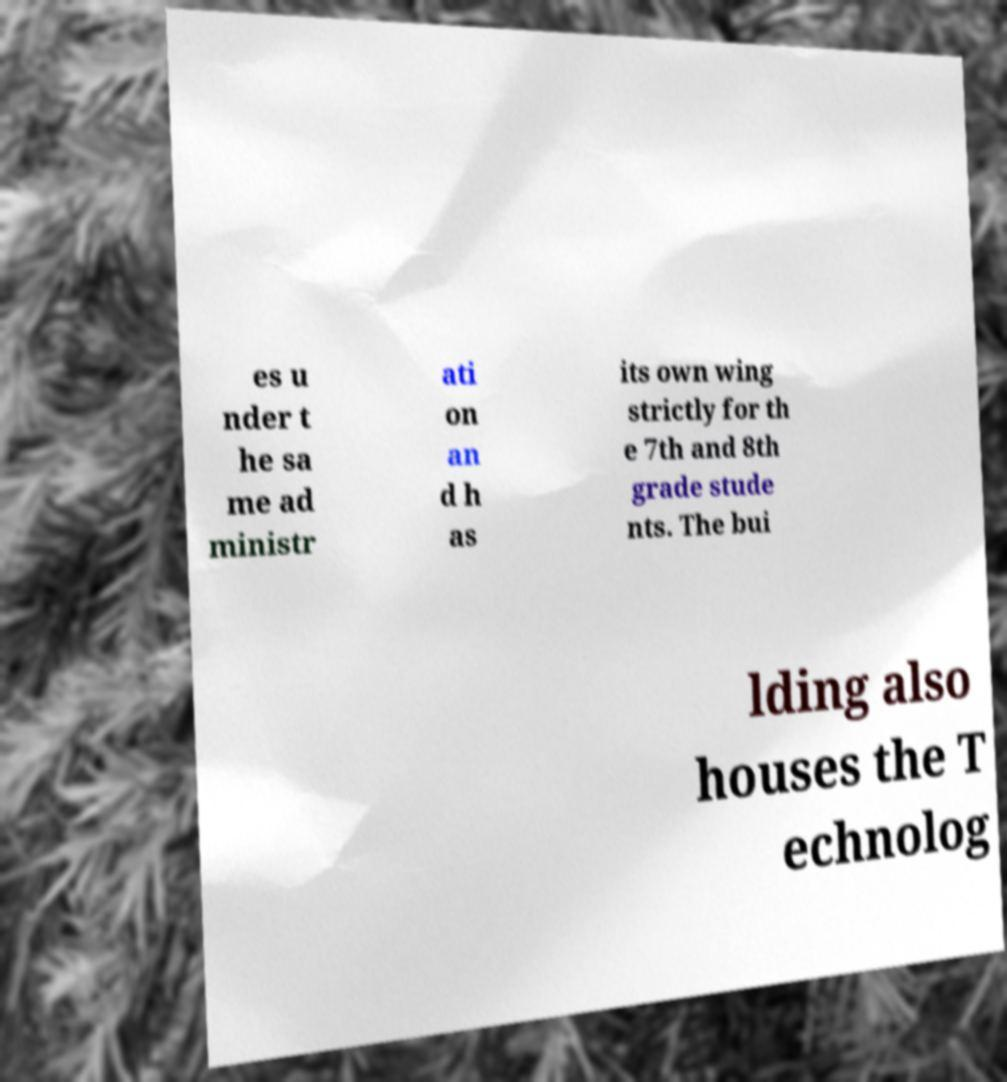Can you accurately transcribe the text from the provided image for me? es u nder t he sa me ad ministr ati on an d h as its own wing strictly for th e 7th and 8th grade stude nts. The bui lding also houses the T echnolog 